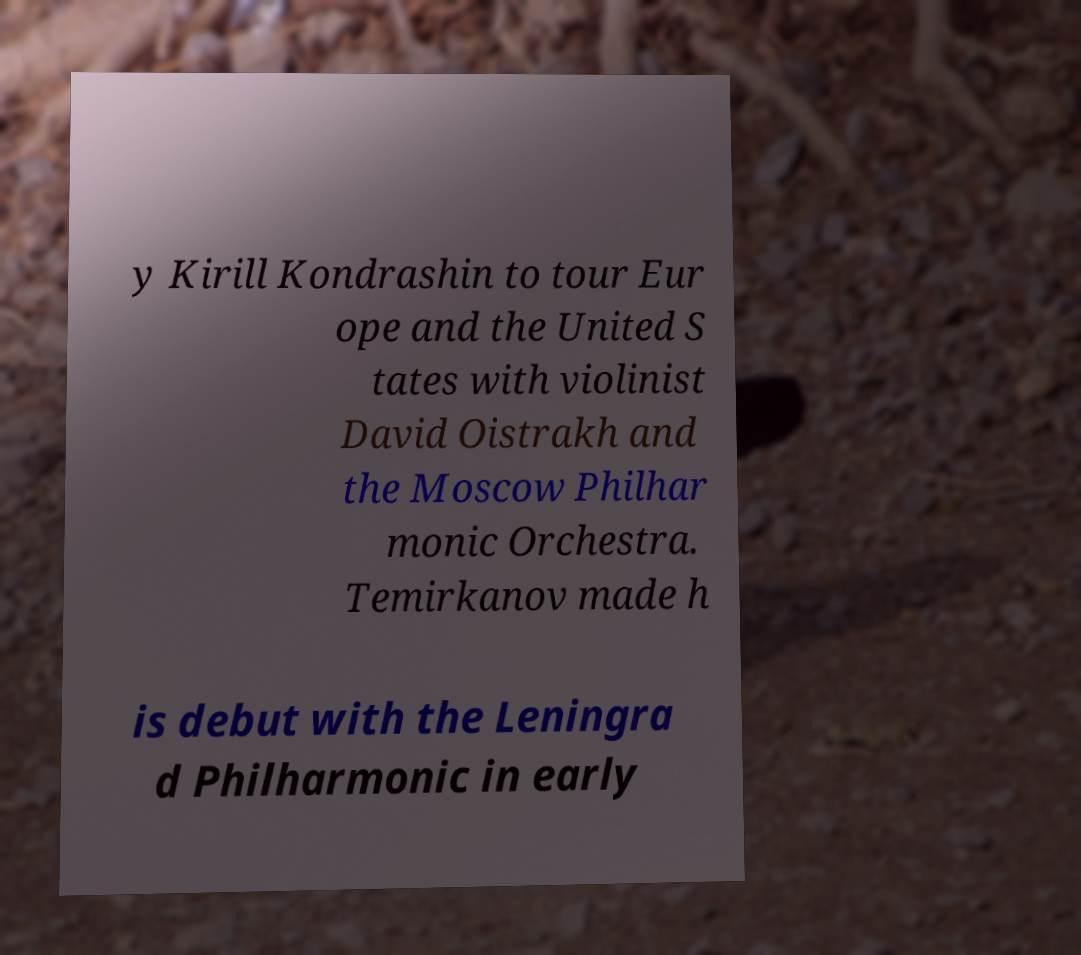Please identify and transcribe the text found in this image. y Kirill Kondrashin to tour Eur ope and the United S tates with violinist David Oistrakh and the Moscow Philhar monic Orchestra. Temirkanov made h is debut with the Leningra d Philharmonic in early 